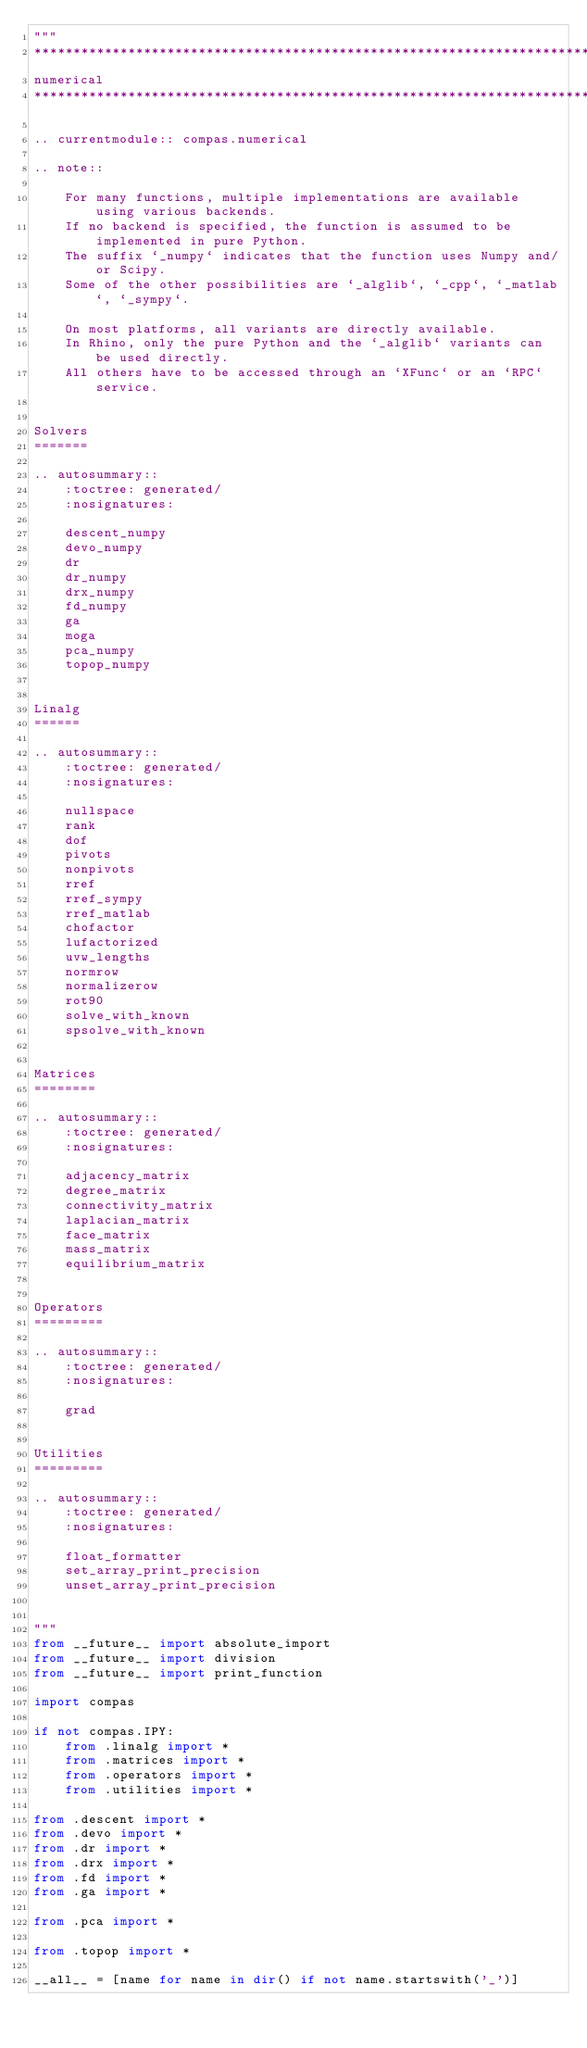Convert code to text. <code><loc_0><loc_0><loc_500><loc_500><_Python_>"""
********************************************************************************
numerical
********************************************************************************

.. currentmodule:: compas.numerical

.. note::

    For many functions, multiple implementations are available using various backends.
    If no backend is specified, the function is assumed to be implemented in pure Python.
    The suffix `_numpy` indicates that the function uses Numpy and/or Scipy.
    Some of the other possibilities are `_alglib`, `_cpp`, `_matlab`, `_sympy`.

    On most platforms, all variants are directly available.
    In Rhino, only the pure Python and the `_alglib` variants can be used directly.
    All others have to be accessed through an `XFunc` or an `RPC` service.


Solvers
=======

.. autosummary::
    :toctree: generated/
    :nosignatures:

    descent_numpy
    devo_numpy
    dr
    dr_numpy
    drx_numpy
    fd_numpy
    ga
    moga
    pca_numpy
    topop_numpy


Linalg
======

.. autosummary::
    :toctree: generated/
    :nosignatures:

    nullspace
    rank
    dof
    pivots
    nonpivots
    rref
    rref_sympy
    rref_matlab
    chofactor
    lufactorized
    uvw_lengths
    normrow
    normalizerow
    rot90
    solve_with_known
    spsolve_with_known


Matrices
========

.. autosummary::
    :toctree: generated/
    :nosignatures:

    adjacency_matrix
    degree_matrix
    connectivity_matrix
    laplacian_matrix
    face_matrix
    mass_matrix
    equilibrium_matrix


Operators
=========

.. autosummary::
    :toctree: generated/
    :nosignatures:

    grad


Utilities
=========

.. autosummary::
    :toctree: generated/
    :nosignatures:

    float_formatter
    set_array_print_precision
    unset_array_print_precision


"""
from __future__ import absolute_import
from __future__ import division
from __future__ import print_function

import compas

if not compas.IPY:
    from .linalg import *
    from .matrices import *
    from .operators import *
    from .utilities import *

from .descent import *
from .devo import *
from .dr import *
from .drx import *
from .fd import *
from .ga import *

from .pca import *

from .topop import *

__all__ = [name for name in dir() if not name.startswith('_')]
</code> 